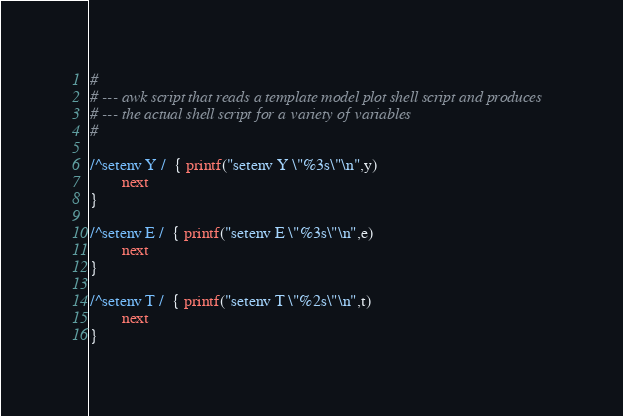<code> <loc_0><loc_0><loc_500><loc_500><_Awk_>#
# --- awk script that reads a template model plot shell script and produces
# --- the actual shell script for a variety of variables
#

/^setenv Y /  { printf("setenv Y \"%3s\"\n",y)
		next
}

/^setenv E /  { printf("setenv E \"%3s\"\n",e)
		next
}

/^setenv T /  { printf("setenv T \"%2s\"\n",t)
		next
}
</code> 